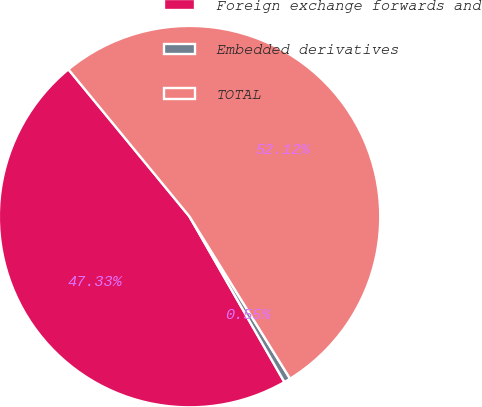<chart> <loc_0><loc_0><loc_500><loc_500><pie_chart><fcel>Foreign exchange forwards and<fcel>Embedded derivatives<fcel>TOTAL<nl><fcel>47.33%<fcel>0.55%<fcel>52.12%<nl></chart> 